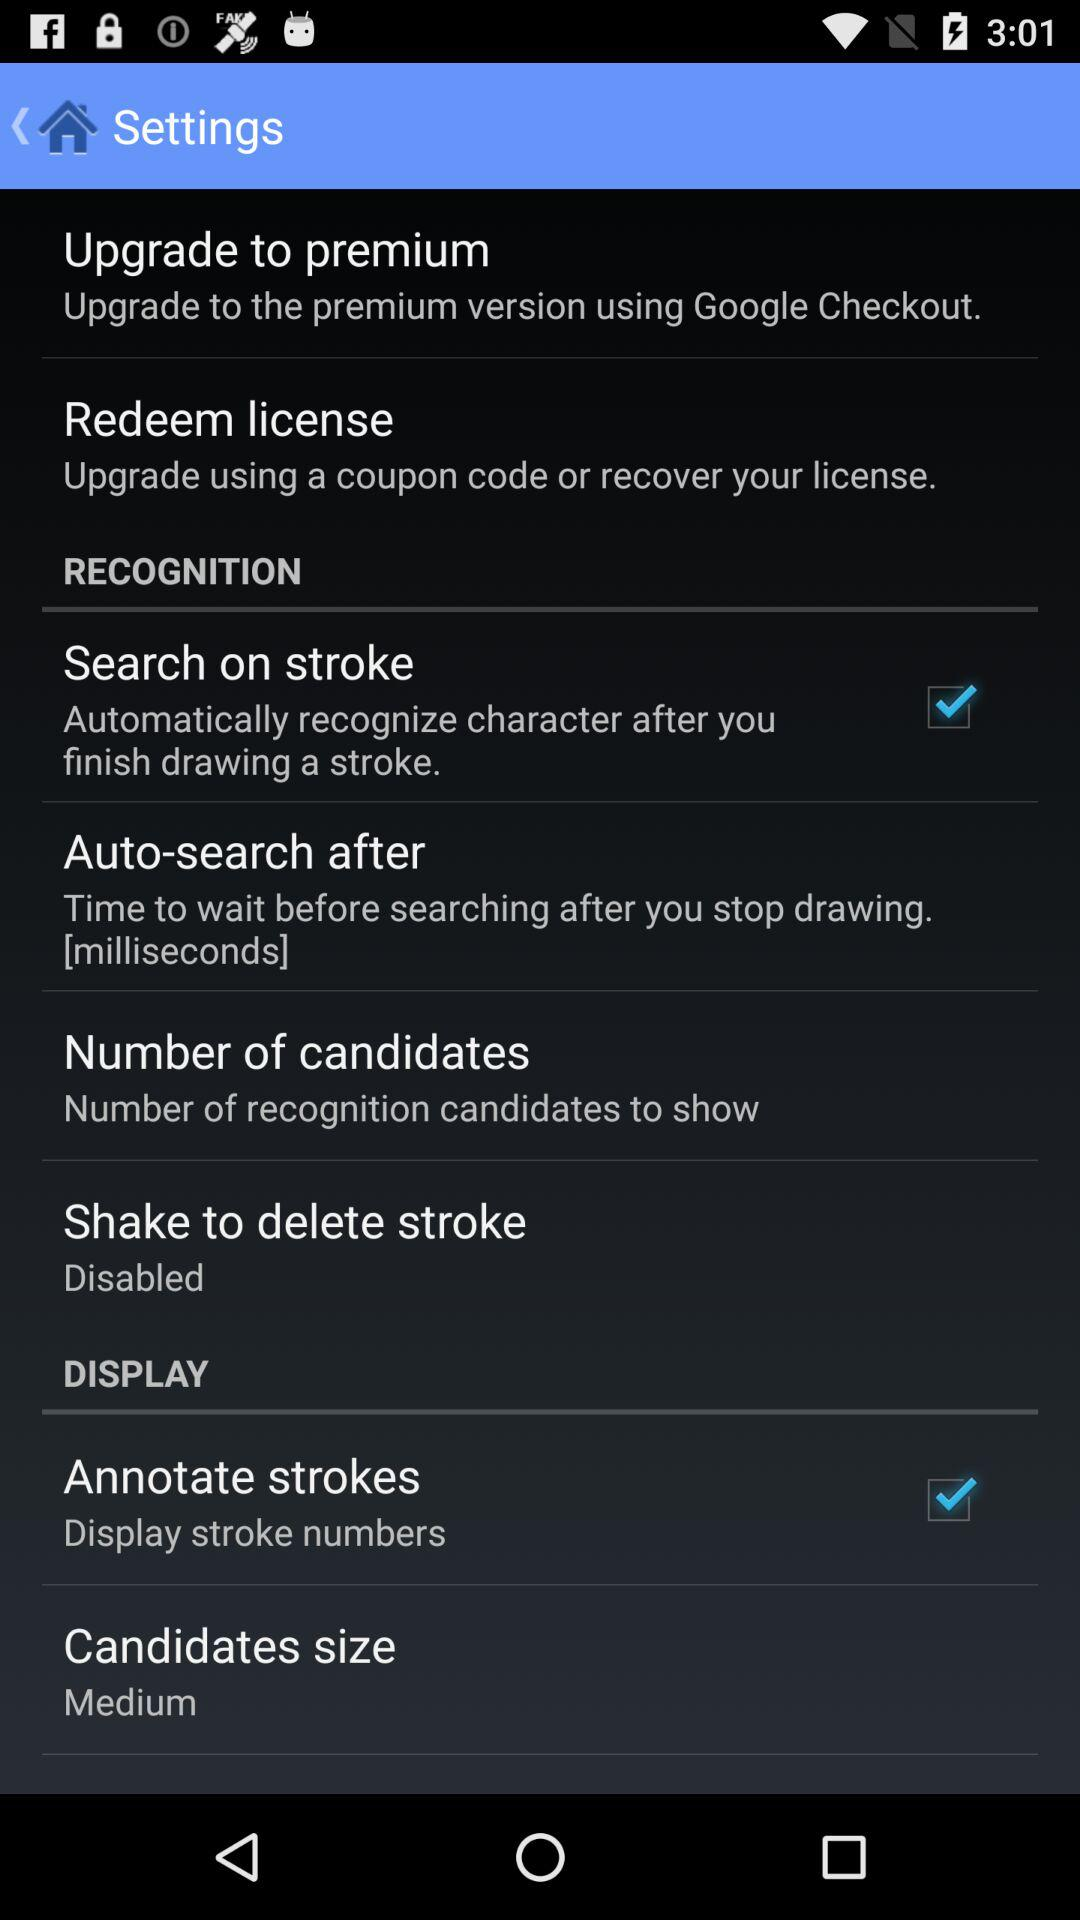How many candidates are there?
When the provided information is insufficient, respond with <no answer>. <no answer> 